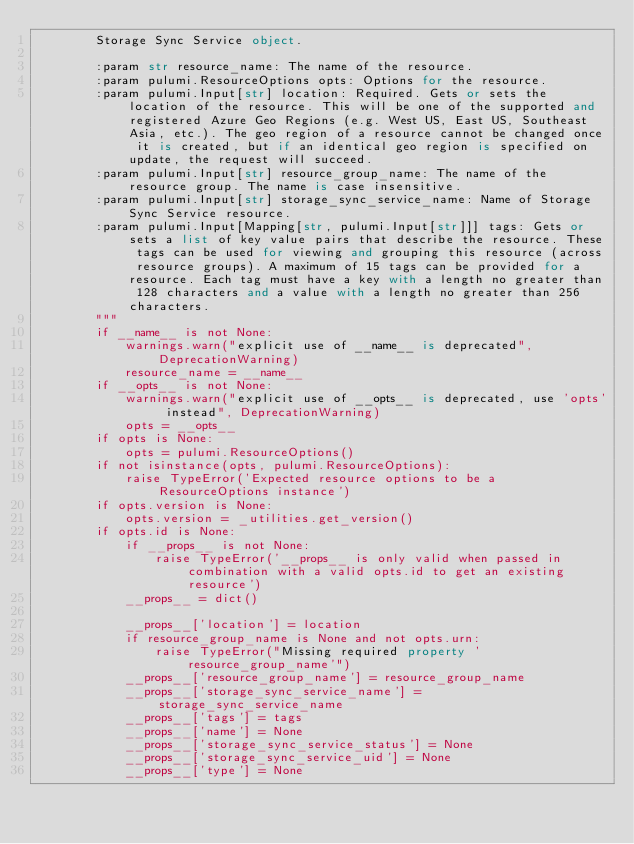Convert code to text. <code><loc_0><loc_0><loc_500><loc_500><_Python_>        Storage Sync Service object.

        :param str resource_name: The name of the resource.
        :param pulumi.ResourceOptions opts: Options for the resource.
        :param pulumi.Input[str] location: Required. Gets or sets the location of the resource. This will be one of the supported and registered Azure Geo Regions (e.g. West US, East US, Southeast Asia, etc.). The geo region of a resource cannot be changed once it is created, but if an identical geo region is specified on update, the request will succeed.
        :param pulumi.Input[str] resource_group_name: The name of the resource group. The name is case insensitive.
        :param pulumi.Input[str] storage_sync_service_name: Name of Storage Sync Service resource.
        :param pulumi.Input[Mapping[str, pulumi.Input[str]]] tags: Gets or sets a list of key value pairs that describe the resource. These tags can be used for viewing and grouping this resource (across resource groups). A maximum of 15 tags can be provided for a resource. Each tag must have a key with a length no greater than 128 characters and a value with a length no greater than 256 characters.
        """
        if __name__ is not None:
            warnings.warn("explicit use of __name__ is deprecated", DeprecationWarning)
            resource_name = __name__
        if __opts__ is not None:
            warnings.warn("explicit use of __opts__ is deprecated, use 'opts' instead", DeprecationWarning)
            opts = __opts__
        if opts is None:
            opts = pulumi.ResourceOptions()
        if not isinstance(opts, pulumi.ResourceOptions):
            raise TypeError('Expected resource options to be a ResourceOptions instance')
        if opts.version is None:
            opts.version = _utilities.get_version()
        if opts.id is None:
            if __props__ is not None:
                raise TypeError('__props__ is only valid when passed in combination with a valid opts.id to get an existing resource')
            __props__ = dict()

            __props__['location'] = location
            if resource_group_name is None and not opts.urn:
                raise TypeError("Missing required property 'resource_group_name'")
            __props__['resource_group_name'] = resource_group_name
            __props__['storage_sync_service_name'] = storage_sync_service_name
            __props__['tags'] = tags
            __props__['name'] = None
            __props__['storage_sync_service_status'] = None
            __props__['storage_sync_service_uid'] = None
            __props__['type'] = None</code> 